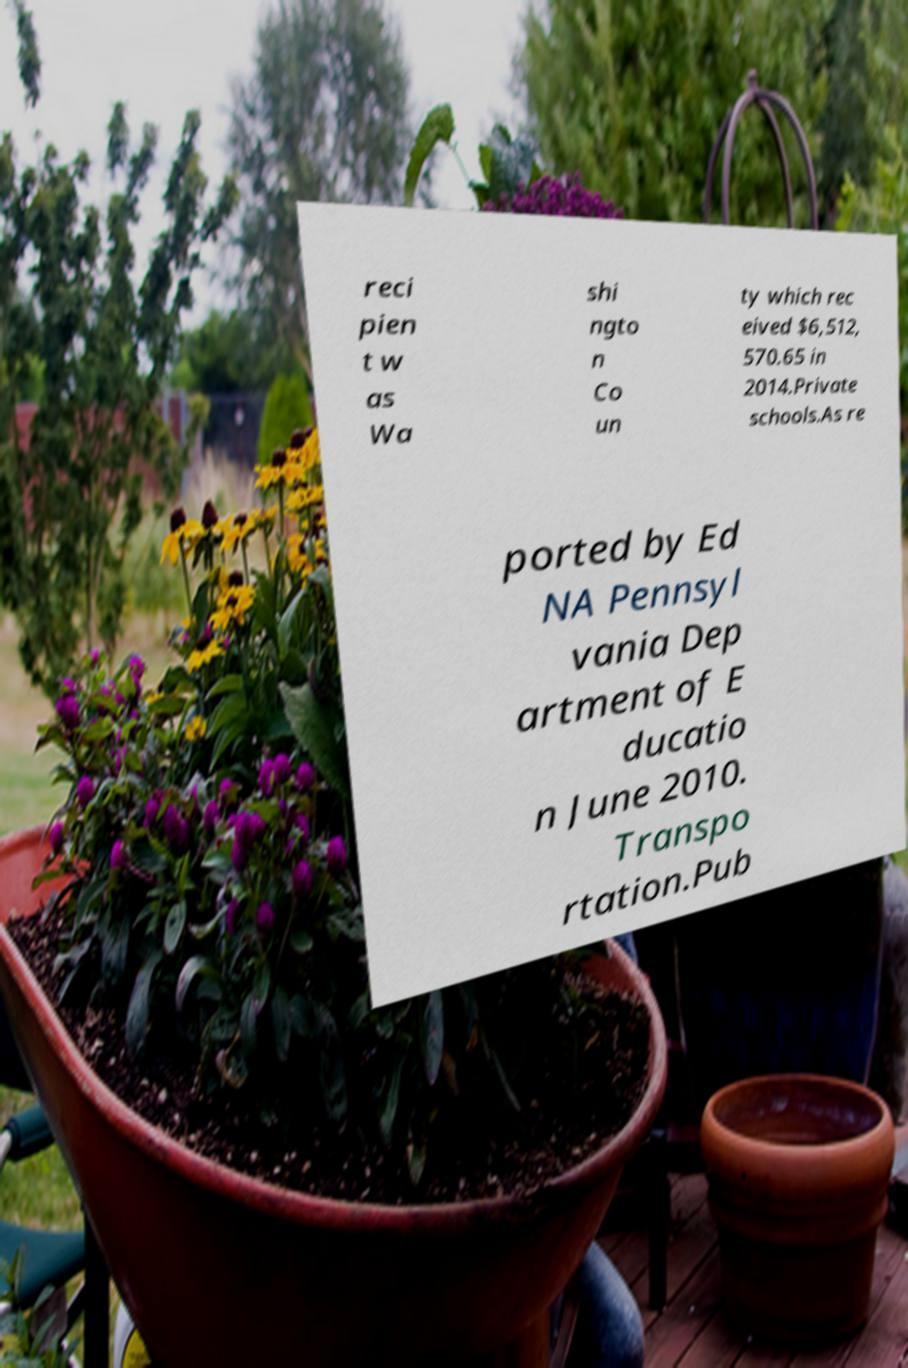I need the written content from this picture converted into text. Can you do that? reci pien t w as Wa shi ngto n Co un ty which rec eived $6,512, 570.65 in 2014.Private schools.As re ported by Ed NA Pennsyl vania Dep artment of E ducatio n June 2010. Transpo rtation.Pub 